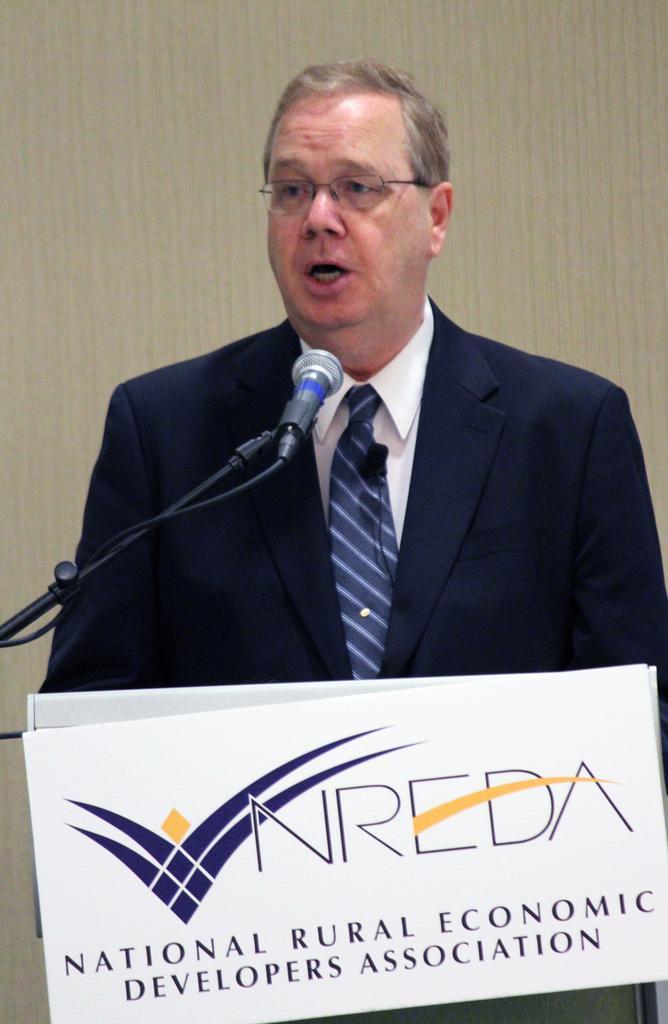Describe this image in one or two sentences. In this picture, in the middle, we can see a man who is wearing a black color suit and talking in front of a microphone. In the background, we can see a wall, at the bottom there is a board, on which some text is written on the board. 